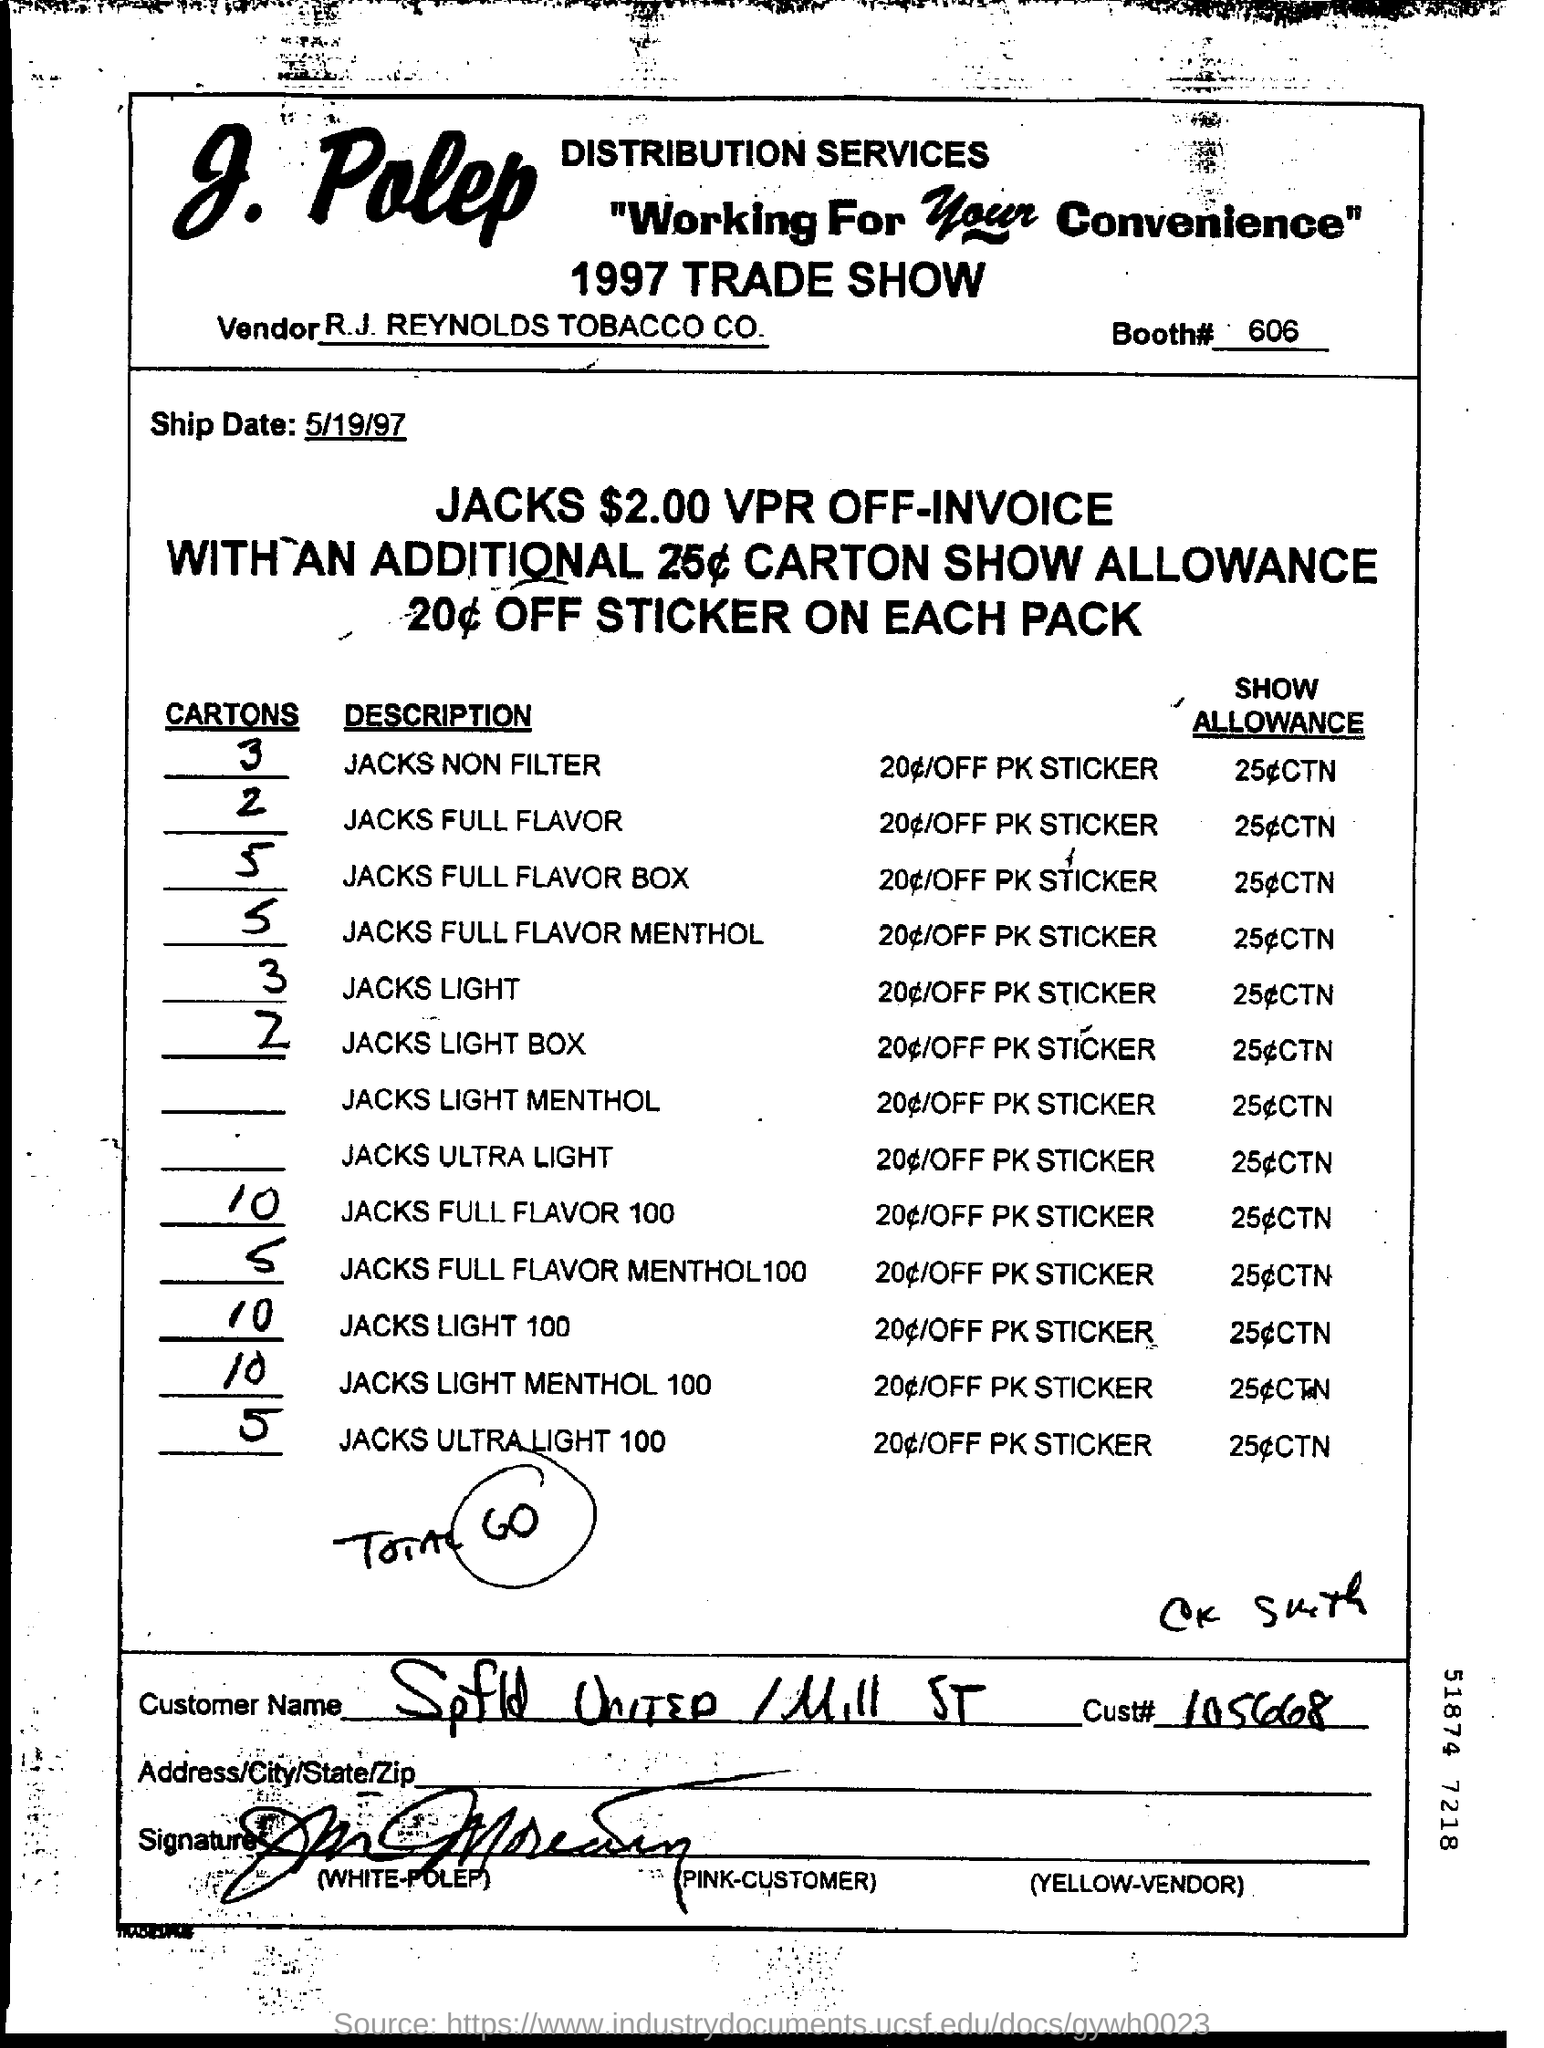What is the Vendor name?
Ensure brevity in your answer.  R.J. REYNOLDS TOBACCO CO. What is the Booth#?
Your response must be concise. 606. What is  the Ship Date?
Offer a terse response. 5/19/97. What is the Cust#?
Provide a succinct answer. 105668. 